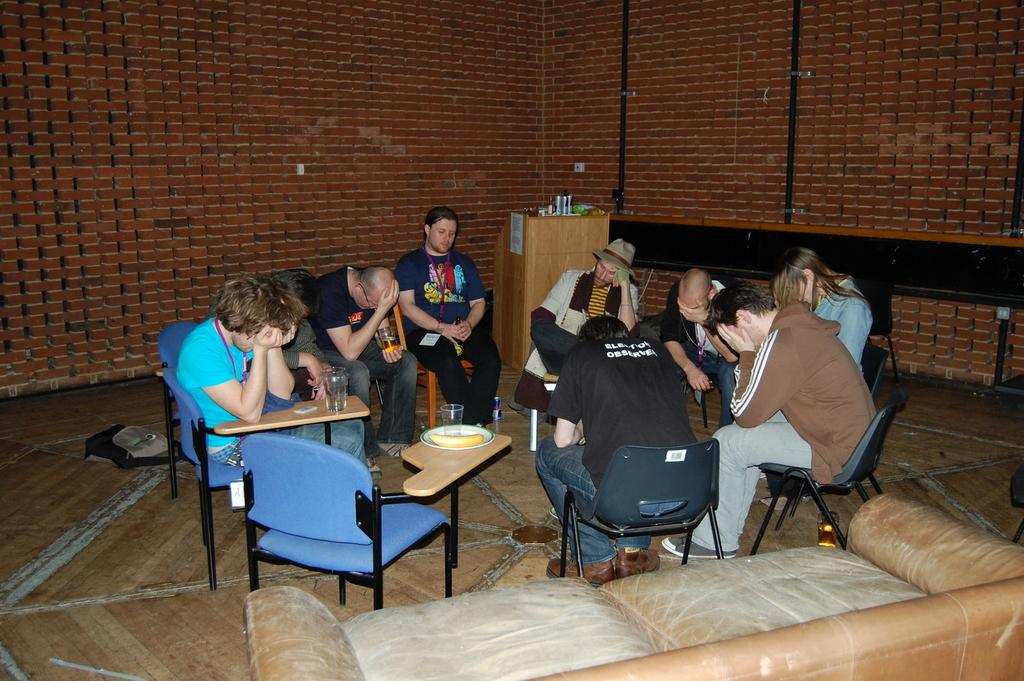Who or what can be seen in the image? There are people in the image. What are the people doing in the image? The people are sitting on chairs. What color are the cherries on the table in the image? There is no table or cherries present in the image; it only shows people sitting on chairs. 